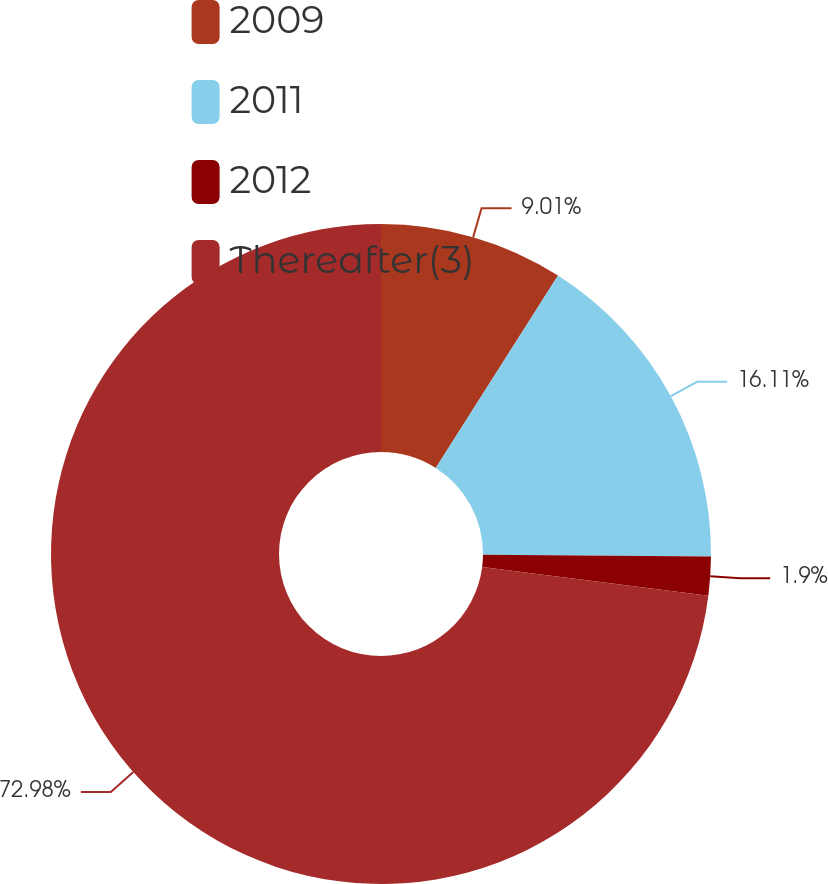<chart> <loc_0><loc_0><loc_500><loc_500><pie_chart><fcel>2009<fcel>2011<fcel>2012<fcel>Thereafter(3)<nl><fcel>9.01%<fcel>16.11%<fcel>1.9%<fcel>72.98%<nl></chart> 